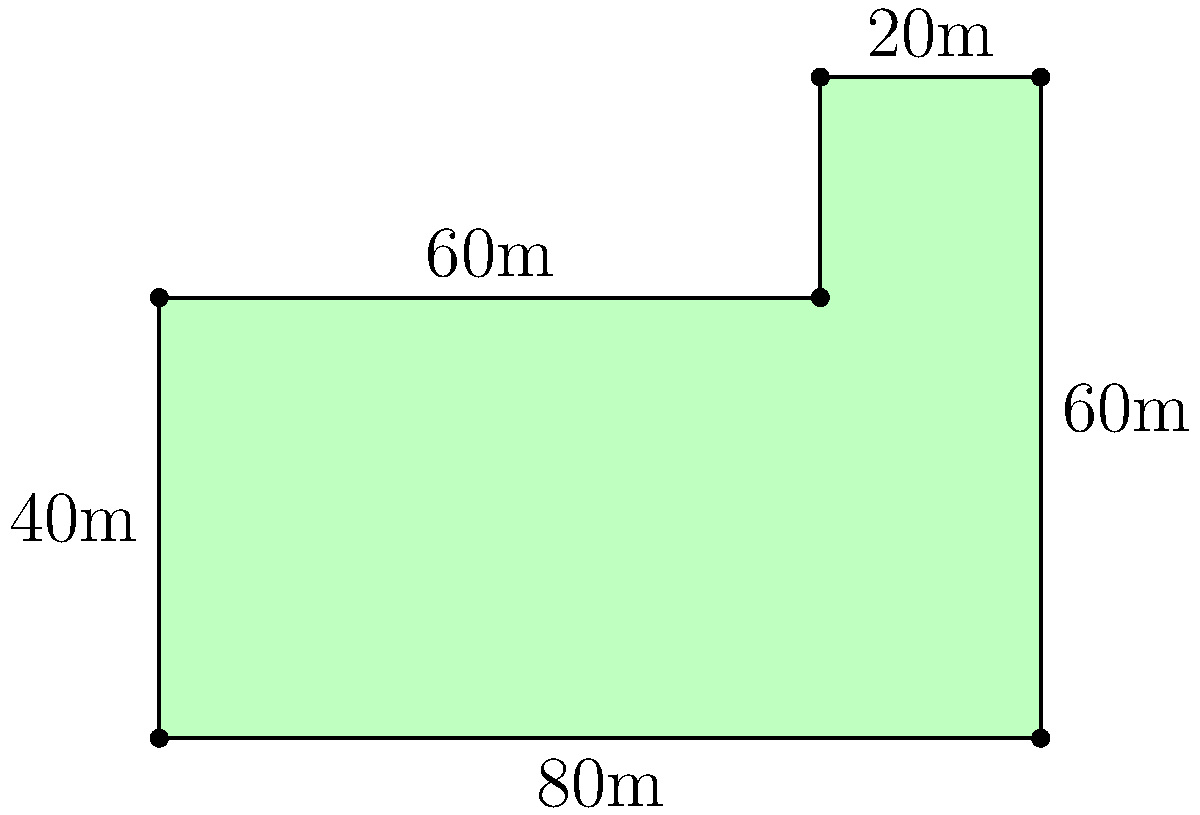After zoning deregulation, a developer acquired an irregularly shaped plot of land. The plot can be divided into a rectangle and an L-shaped area. What is the total area of this plot in square meters? To calculate the area of this irregularly shaped plot, we'll break it down into two parts:

1. Rectangle:
   - Width = 80m
   - Height = 40m
   - Area of rectangle = $80m \times 40m = 3200m^2$

2. L-shaped area:
   - This can be seen as a rectangle minus a smaller rectangle
   - Larger rectangle: 20m x 60m
   - Smaller rectangle: 20m x 40m
   - Area of L-shape = $(20m \times 60m) - (20m \times 40m)$
                     = $1200m^2 - 800m^2 = 400m^2$

3. Total area:
   - Sum of both parts = $3200m^2 + 400m^2 = 3600m^2$

Therefore, the total area of the plot is 3600 square meters.
Answer: $3600m^2$ 